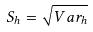<formula> <loc_0><loc_0><loc_500><loc_500>S _ { h } = \sqrt { V a r _ { h } }</formula> 